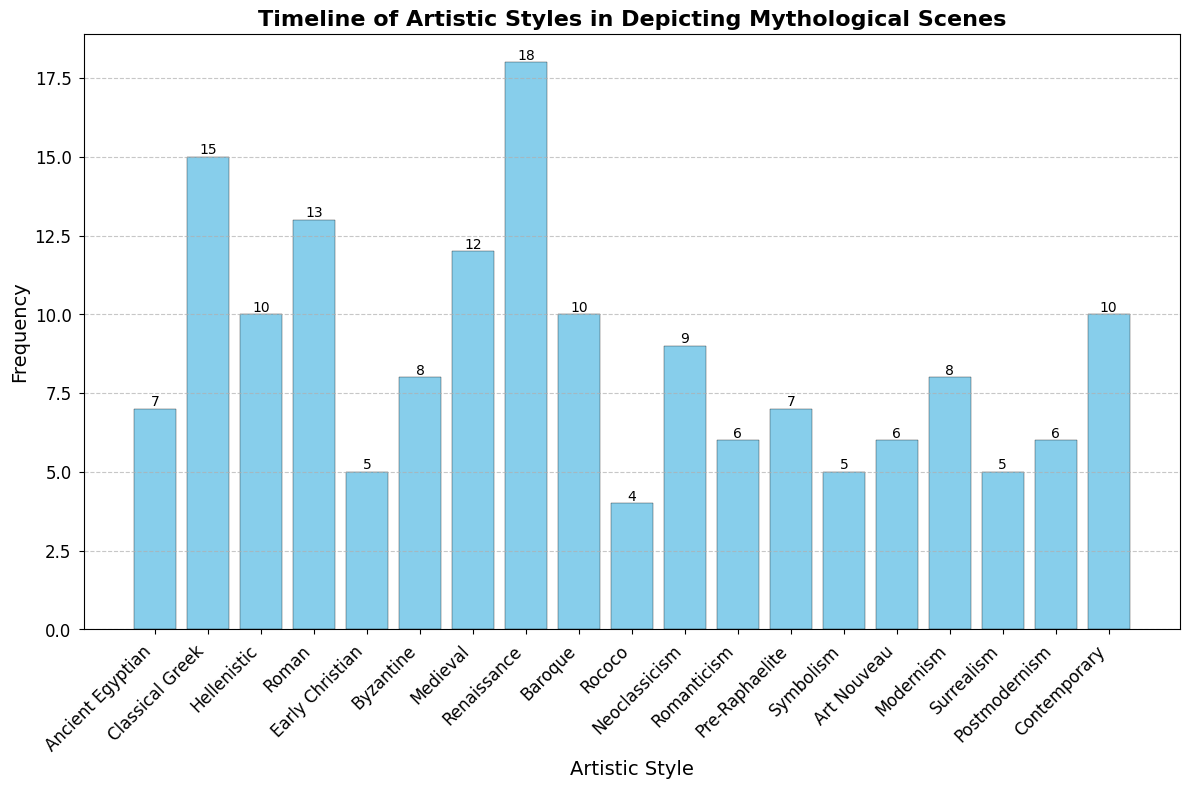What artistic style has the highest frequency in depicting mythological scenes? By looking at the heights of the bars in the histogram, it is clear that the "Renaissance" style has the highest bar, indicating the highest frequency.
Answer: Renaissance Which artistic style has the lowest frequency in depicting mythological scenes? The smallest bar corresponds to the "Rococo" style, indicating the lowest frequency.
Answer: Rococo Compare the frequency of the "Classical Greek" style with the "Renaissance" style. Which one is higher and by how much? The frequency of the "Classical Greek" style is 15 and for the "Renaissance" style is 18. The "Renaissance" style is higher by 3.
Answer: Renaissance by 3 What is the sum of frequencies for the "Modernism" and "Contemporary" styles? The frequency for "Modernism" is 8 and for "Contemporary" it is 10. Summing them up gives 8 + 10 = 18.
Answer: 18 How does the frequency of the "Medieval" style compare to the "Roman" style? The "Medieval" style has a frequency of 12 and the "Roman" style has a frequency of 13. The "Roman" style is slightly higher by 1.
Answer: Roman by 1 Which artistic styles have a frequency of exactly 6? By looking at the histogram, the styles "Romanticism" and "Art Nouveau" both have a bar height of 6.
Answer: Romanticism, Art Nouveau What is the average frequency of the styles: "Baroque", "Neoclassicism", and "Symbolism"? The frequencies are 10 for "Baroque", 9 for "Neoclassicism", and 5 for "Symbolism". The sum is 10 + 9 + 5 = 24 and the average is 24 / 3 = 8.
Answer: 8 How many artistic styles have a frequency greater than 10? The bars that exceed the height of 10 are "Classical Greek", "Roman", "Renaissance", and "Medieval". Thus, there are 4 styles with frequencies greater than 10.
Answer: 4 Is the frequency of the "Pre-Raphaelite" style equal to the frequency of the "Ancient Egyptian" style? The "Pre-Raphaelite" style has a frequency of 7, which is equal to the frequency of the "Ancient Egyptian" style, also 7.
Answer: Yes 